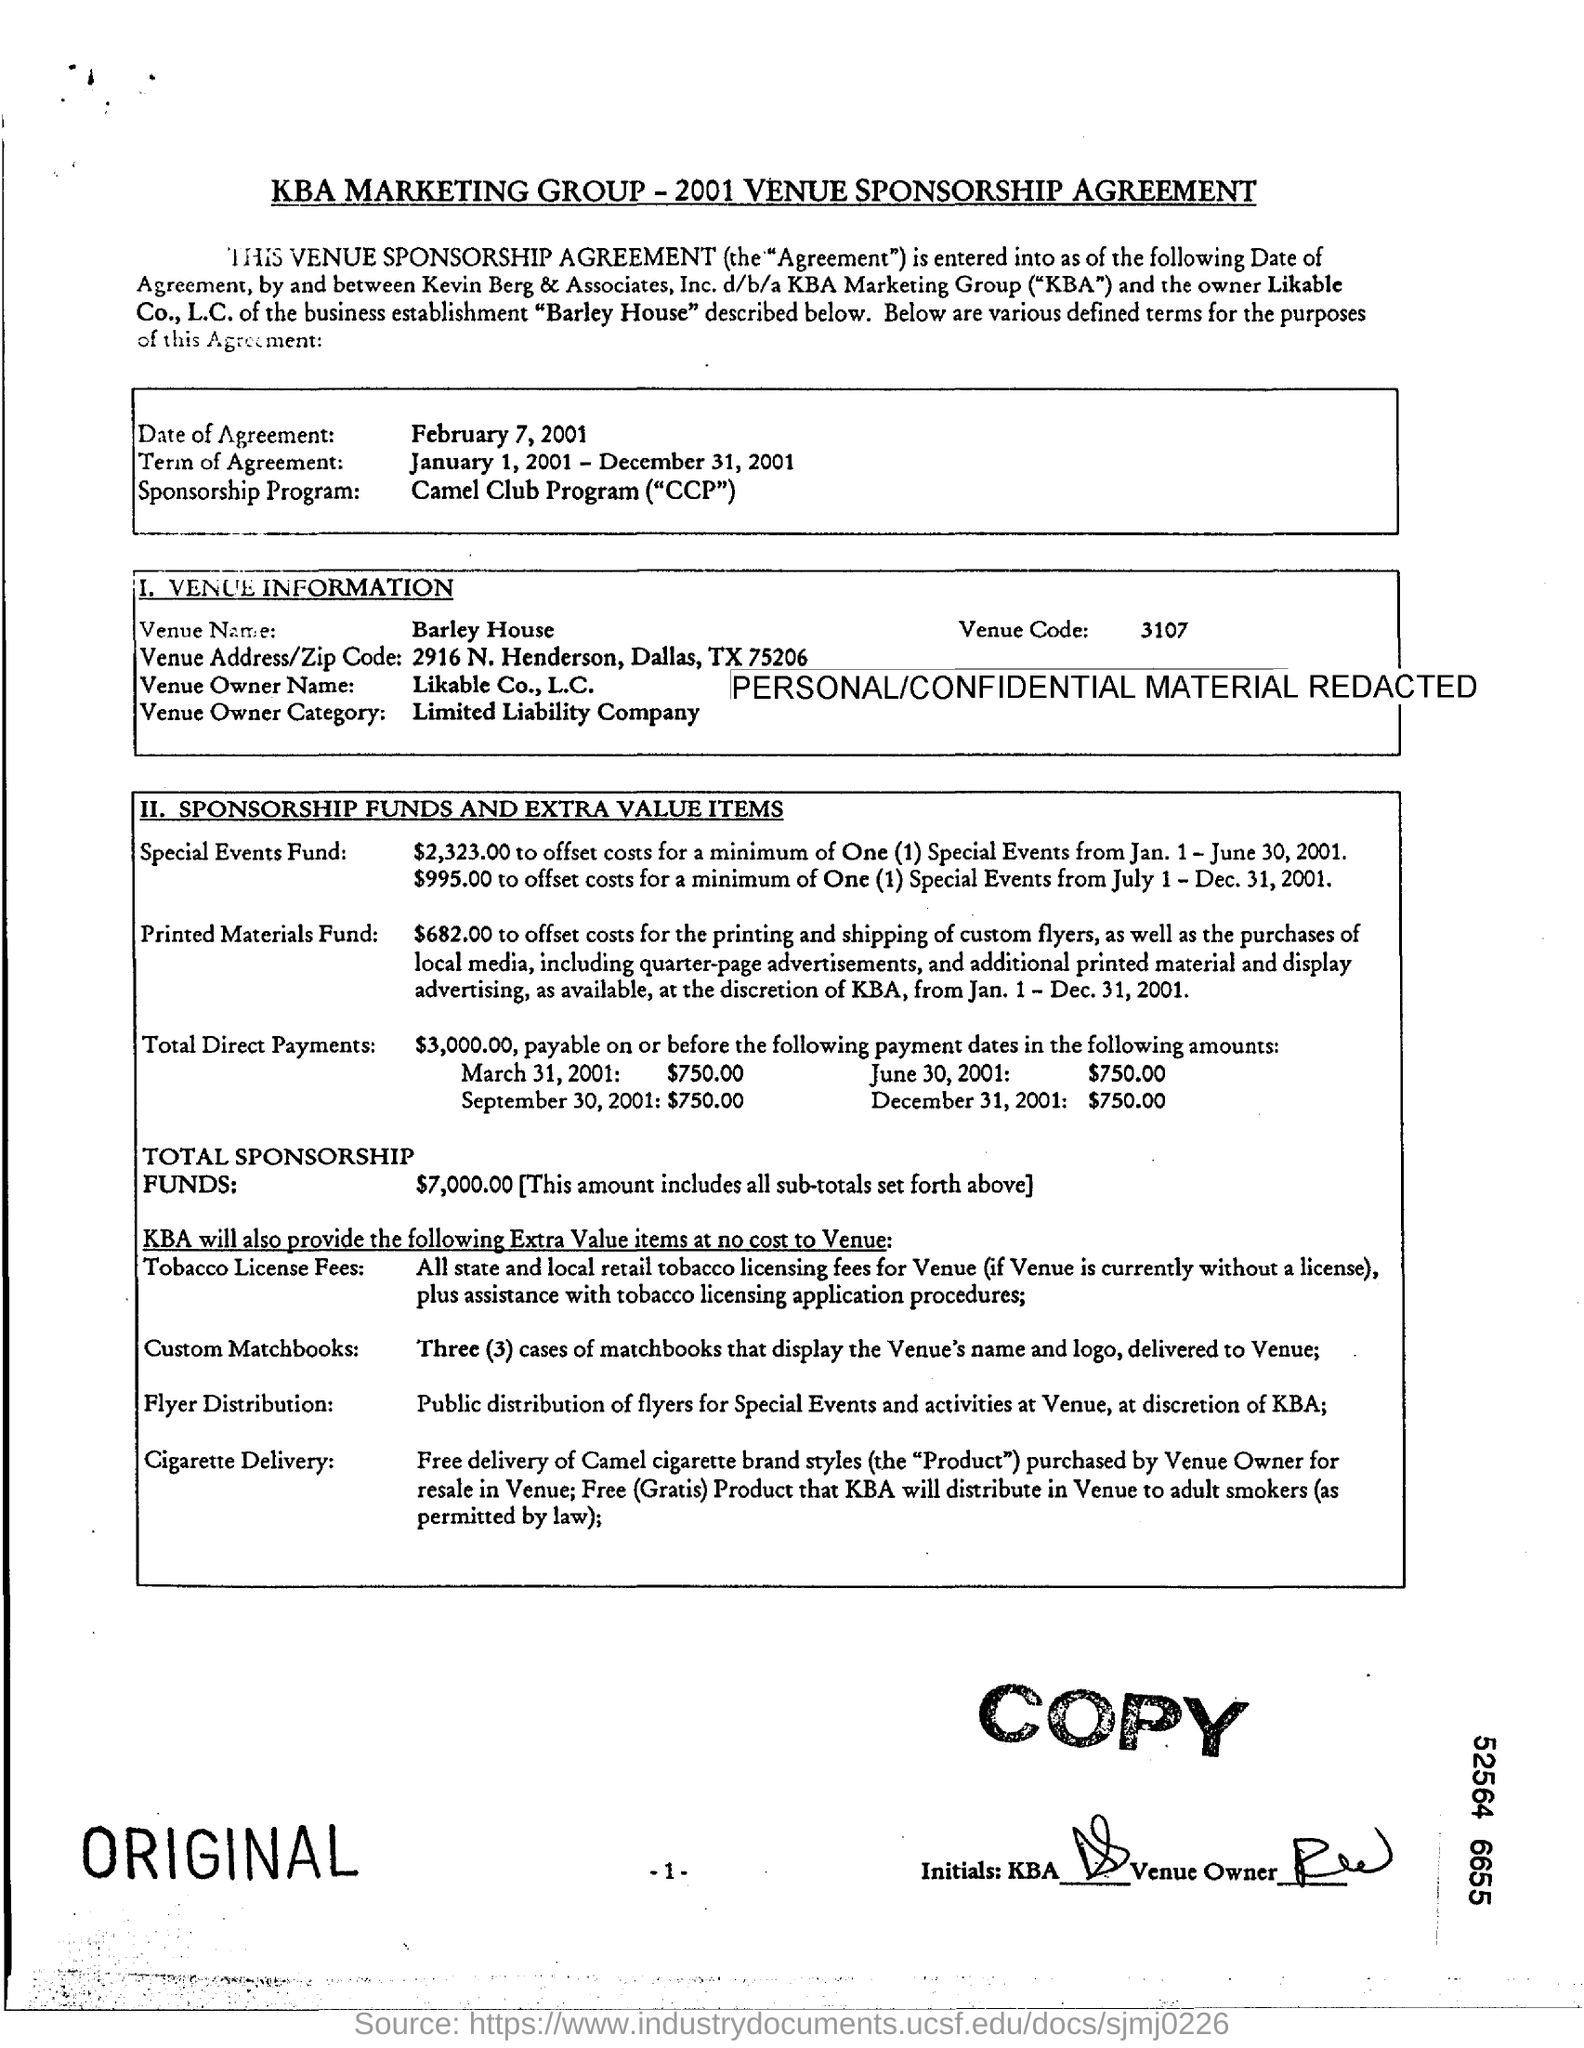Give some essential details in this illustration. What is the venue code?" is a question. "3107" is a numeric code. The sponsorship program name is the CAMEL CLUB PROGRAM (CCP). The total amount of sponsorship funds is $7,000.00. The document title is "KBA Marketing Group-2001 Venue Sponsorship Agreement. February 7, 2001 is the date of agreement. 